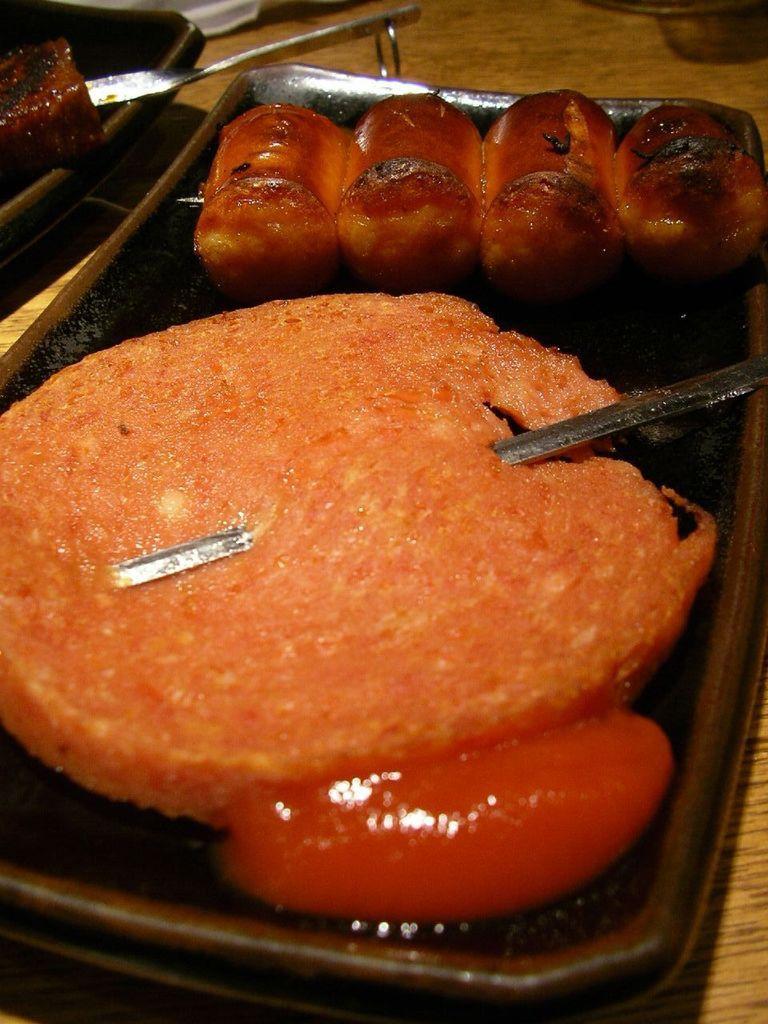In one or two sentences, can you explain what this image depicts? In this image there is food on the tray and there are metal objects in the foreground. And there are objects in the background. And there is a table. 